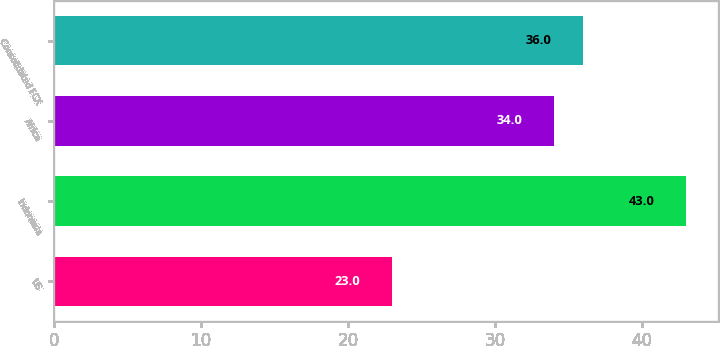Convert chart. <chart><loc_0><loc_0><loc_500><loc_500><bar_chart><fcel>US<fcel>Indonesia<fcel>Africa<fcel>Consolidated FCX<nl><fcel>23<fcel>43<fcel>34<fcel>36<nl></chart> 